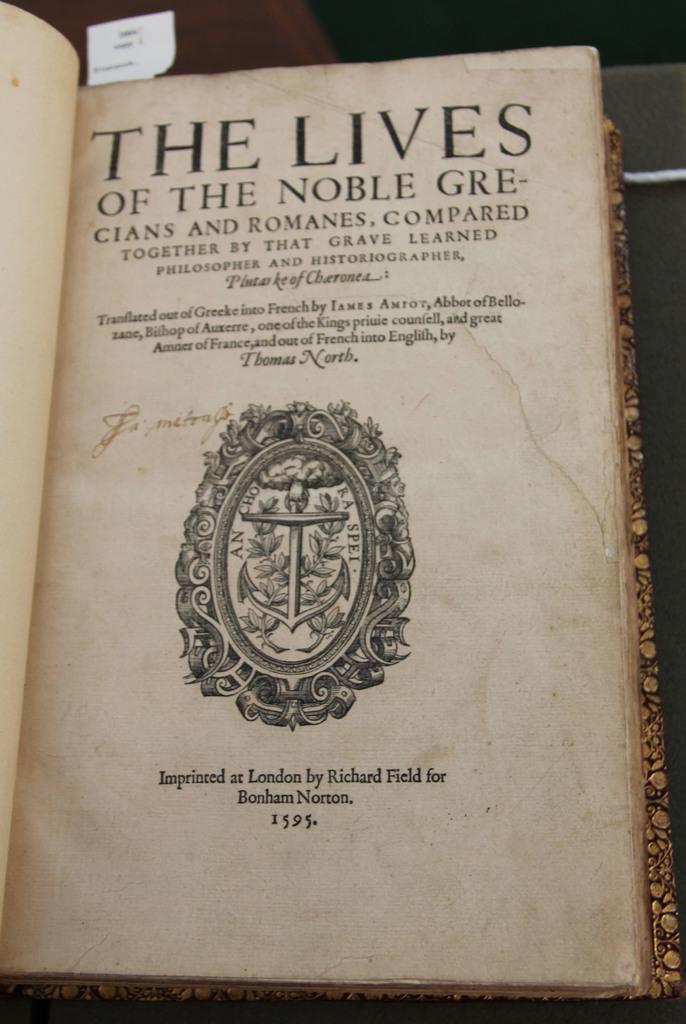What is the name of this book?
Provide a succinct answer. The lives of the noble grecians and romanes compared. What year is printed at the bottom of the page?
Offer a very short reply. 1595. 